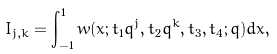Convert formula to latex. <formula><loc_0><loc_0><loc_500><loc_500>I _ { j , k } & = \int _ { - 1 } ^ { 1 } w ( x ; t _ { 1 } q ^ { j } , t _ { 2 } q ^ { k } , t _ { 3 } , t _ { 4 } ; q ) d x ,</formula> 